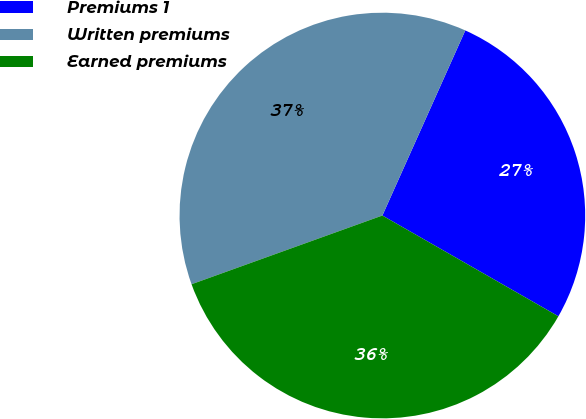Convert chart. <chart><loc_0><loc_0><loc_500><loc_500><pie_chart><fcel>Premiums 1<fcel>Written premiums<fcel>Earned premiums<nl><fcel>26.57%<fcel>37.2%<fcel>36.22%<nl></chart> 